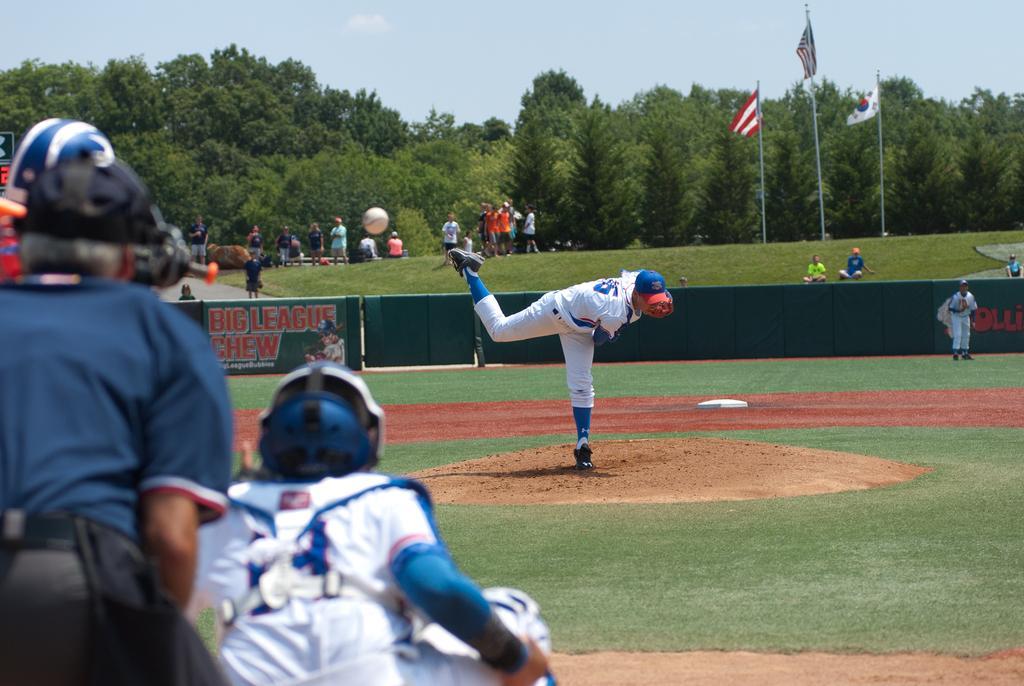Can you describe this image briefly? On the left side, there are two persons in different color dresses, bending. In front of them, there is a person bowling on the ground, on which there is grass. In the background, there is another person standing, there is a green color fence, there are persons, flags attached to the poles, trees and there are clouds in the sky. 